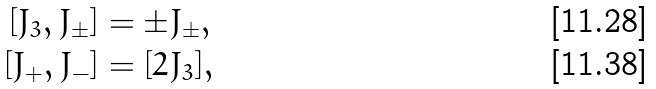Convert formula to latex. <formula><loc_0><loc_0><loc_500><loc_500>[ J _ { 3 } , J _ { \pm } ] & = \pm J _ { \pm } , \\ [ J _ { + } , J _ { - } ] & = [ 2 J _ { 3 } ] ,</formula> 